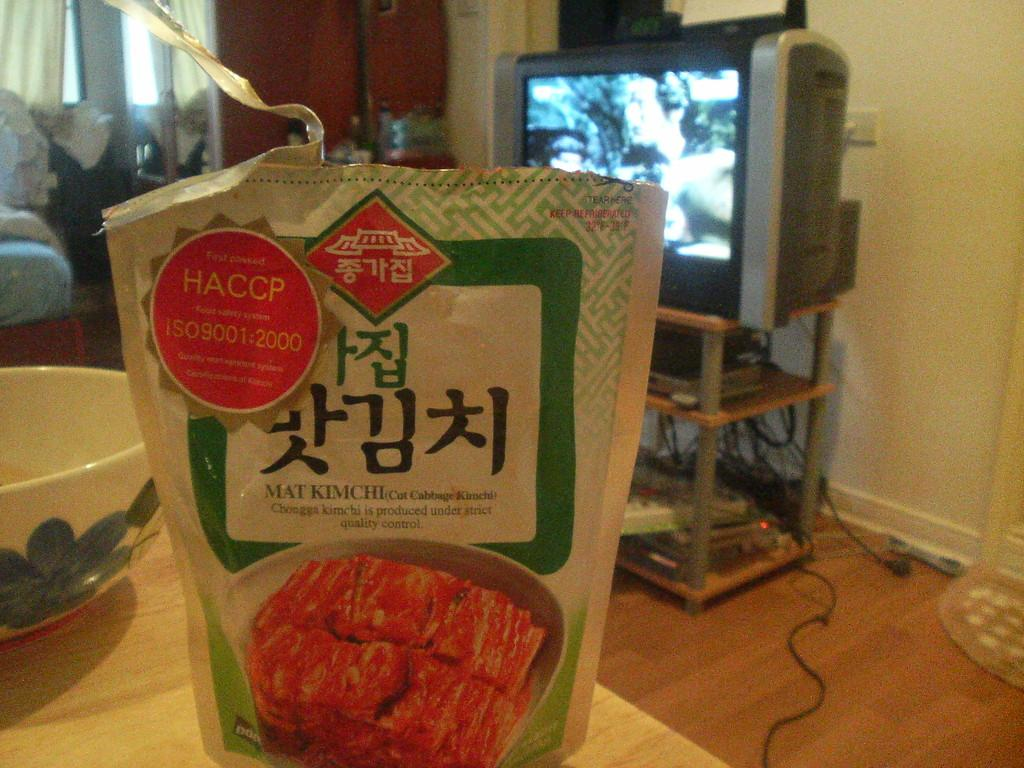Provide a one-sentence caption for the provided image. A bag for a packaged meat product with Asian writing on it. 